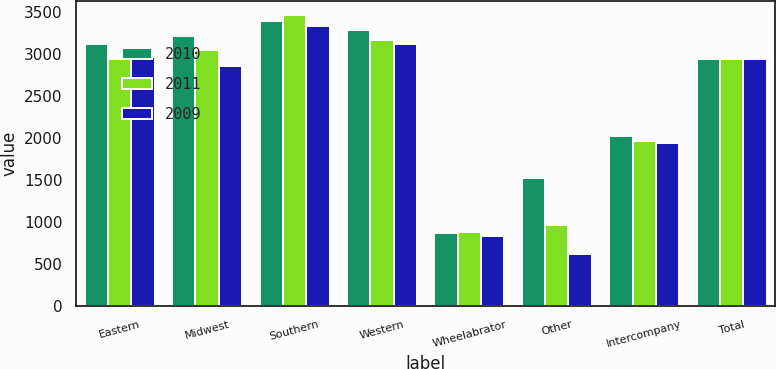Convert chart. <chart><loc_0><loc_0><loc_500><loc_500><stacked_bar_chart><ecel><fcel>Eastern<fcel>Midwest<fcel>Southern<fcel>Western<fcel>Wheelabrator<fcel>Other<fcel>Intercompany<fcel>Total<nl><fcel>2010<fcel>3115<fcel>3213<fcel>3390<fcel>3282<fcel>877<fcel>1532<fcel>2031<fcel>2943<nl><fcel>2011<fcel>2943<fcel>3048<fcel>3461<fcel>3173<fcel>889<fcel>963<fcel>1962<fcel>2943<nl><fcel>2009<fcel>2960<fcel>2855<fcel>3328<fcel>3125<fcel>841<fcel>628<fcel>1946<fcel>2943<nl></chart> 